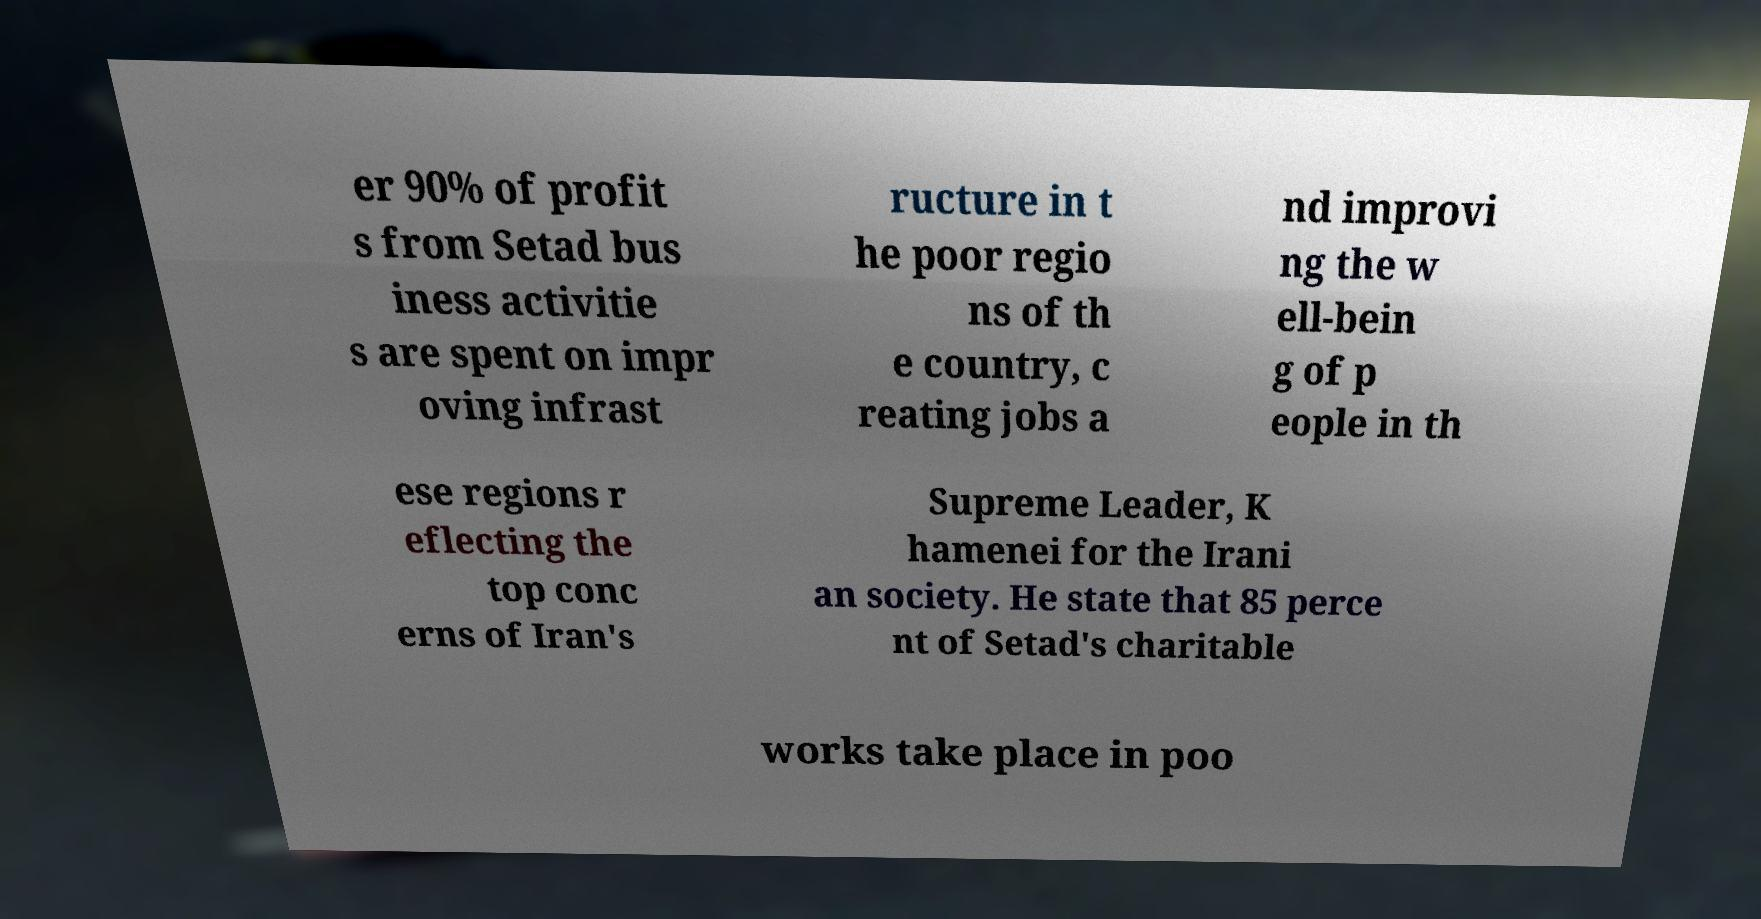Can you read and provide the text displayed in the image?This photo seems to have some interesting text. Can you extract and type it out for me? er 90% of profit s from Setad bus iness activitie s are spent on impr oving infrast ructure in t he poor regio ns of th e country, c reating jobs a nd improvi ng the w ell-bein g of p eople in th ese regions r eflecting the top conc erns of Iran's Supreme Leader, K hamenei for the Irani an society. He state that 85 perce nt of Setad's charitable works take place in poo 